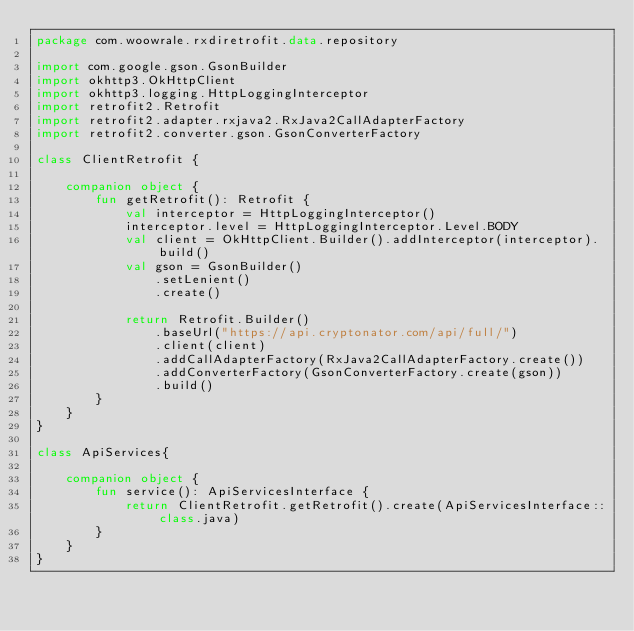<code> <loc_0><loc_0><loc_500><loc_500><_Kotlin_>package com.woowrale.rxdiretrofit.data.repository

import com.google.gson.GsonBuilder
import okhttp3.OkHttpClient
import okhttp3.logging.HttpLoggingInterceptor
import retrofit2.Retrofit
import retrofit2.adapter.rxjava2.RxJava2CallAdapterFactory
import retrofit2.converter.gson.GsonConverterFactory

class ClientRetrofit {

    companion object {
        fun getRetrofit(): Retrofit {
            val interceptor = HttpLoggingInterceptor()
            interceptor.level = HttpLoggingInterceptor.Level.BODY
            val client = OkHttpClient.Builder().addInterceptor(interceptor).build()
            val gson = GsonBuilder()
                .setLenient()
                .create()

            return Retrofit.Builder()
                .baseUrl("https://api.cryptonator.com/api/full/")
                .client(client)
                .addCallAdapterFactory(RxJava2CallAdapterFactory.create())
                .addConverterFactory(GsonConverterFactory.create(gson))
                .build()
        }
    }
}

class ApiServices{

    companion object {
        fun service(): ApiServicesInterface {
            return ClientRetrofit.getRetrofit().create(ApiServicesInterface::class.java)
        }
    }
}</code> 